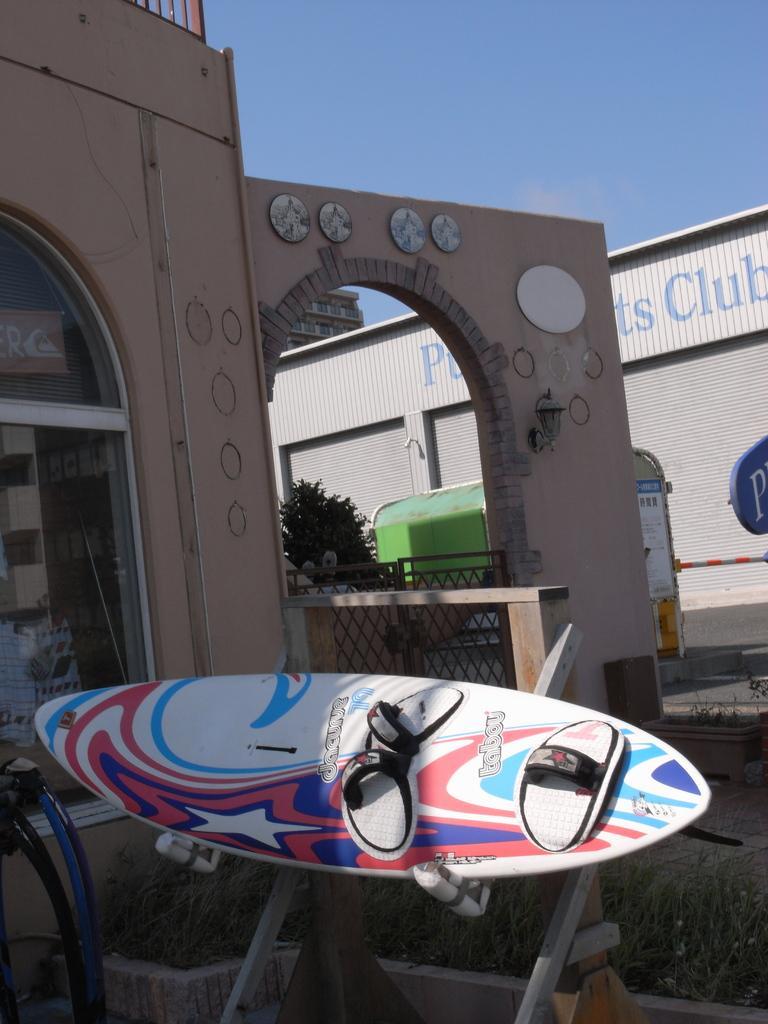Could you give a brief overview of what you see in this image? In this image there is a surfing board, in the background there are buildings and vehicles moving on road and there is the sky. 